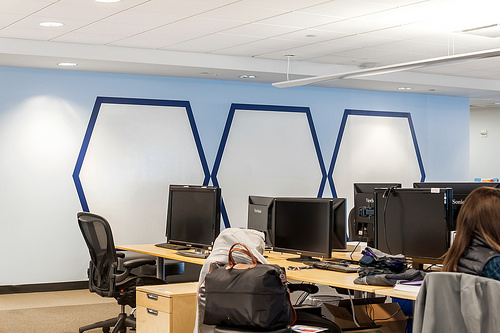<image>
Is the spotlight above the jacket? Yes. The spotlight is positioned above the jacket in the vertical space, higher up in the scene. 